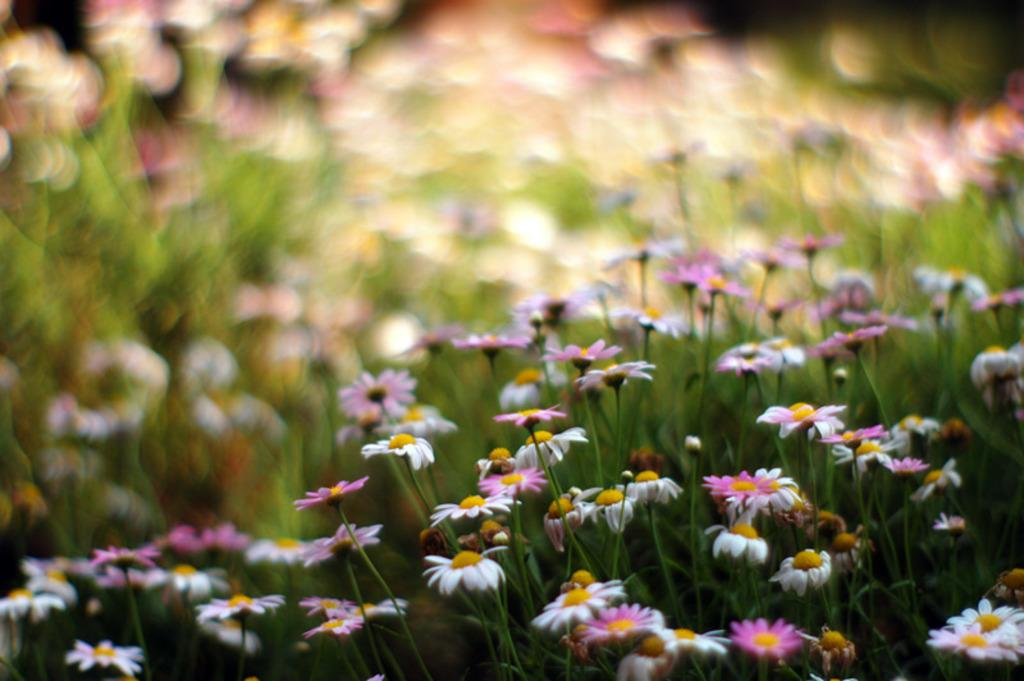What type of objects are present in the image? There are flowers in the image. What colors can be seen in the flowers? The flowers are in white and pink colors. How would you describe the background of the image? The background of the image is in green, white, and pink colors. Is the image clear or blurred in the background? The image is blurred in the background. What story is being told by the cemetery in the image? There is no cemetery present in the image; it features flowers in the foreground and a blurred background. 